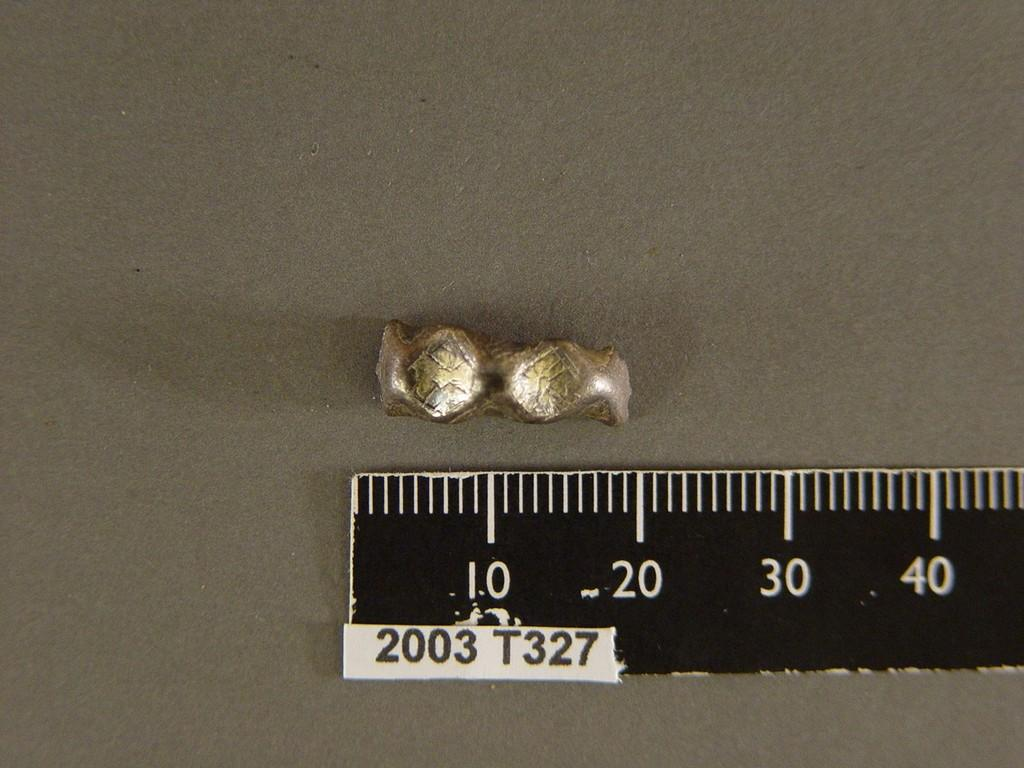<image>
Provide a brief description of the given image. A small metallic object is being measured by a white and black ruler with a white tag that reads 2003 t327 on it. 